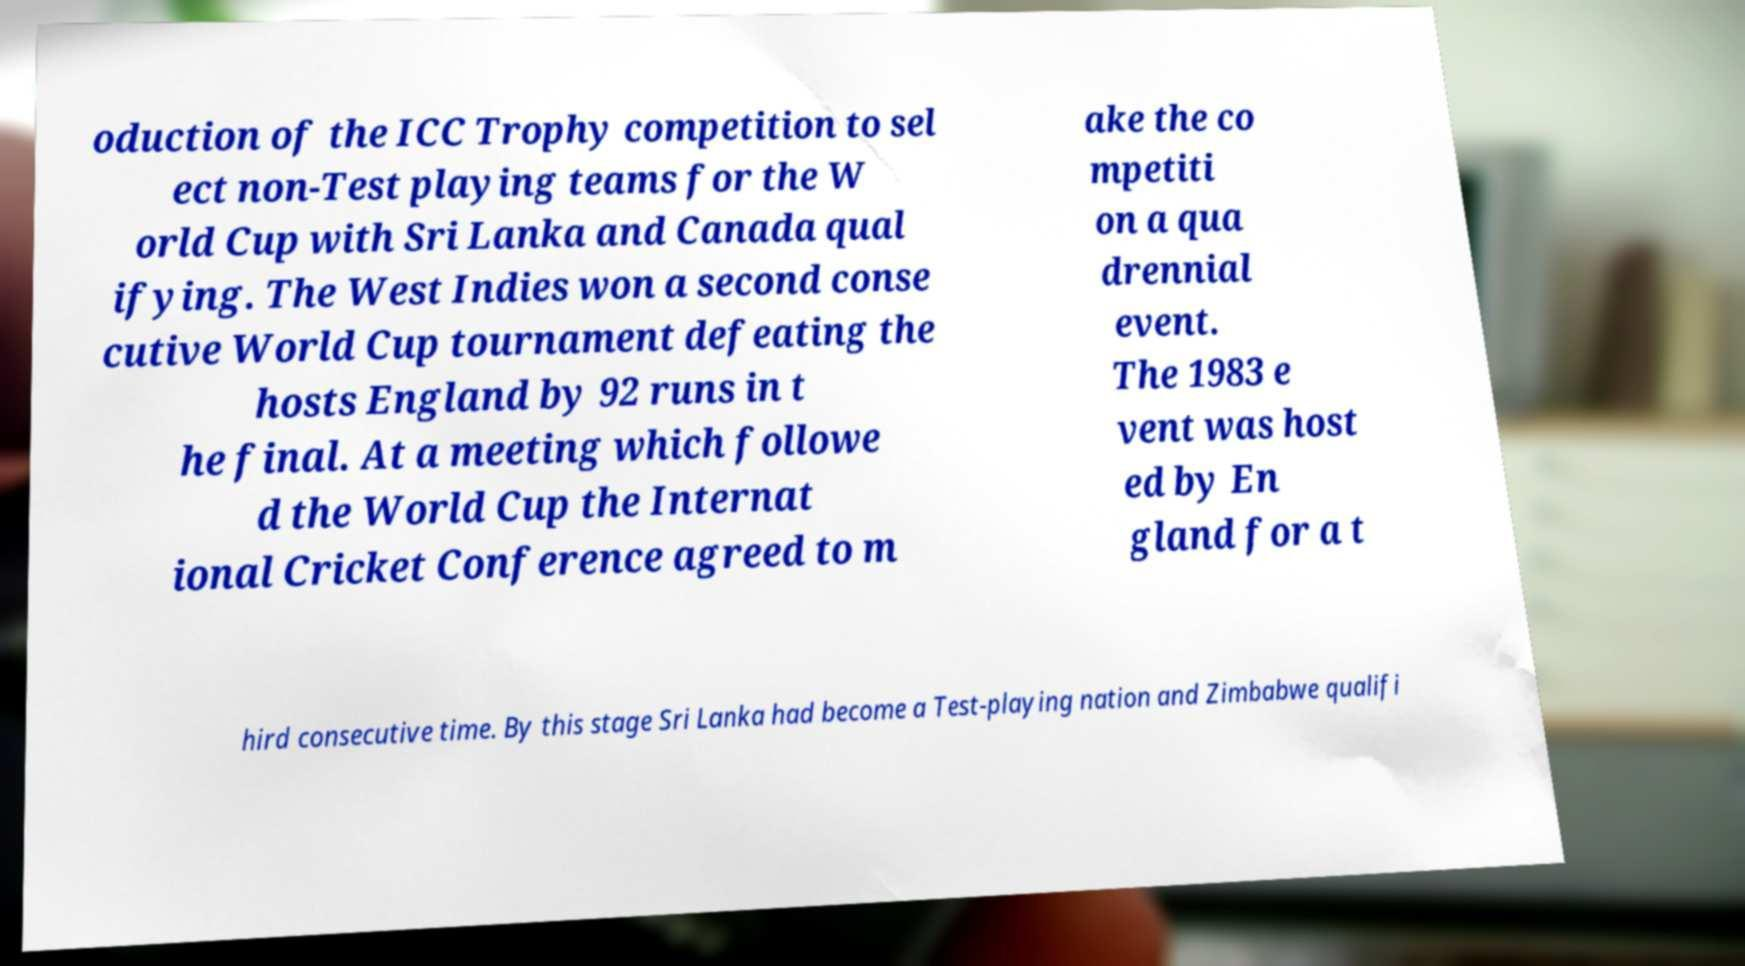What messages or text are displayed in this image? I need them in a readable, typed format. oduction of the ICC Trophy competition to sel ect non-Test playing teams for the W orld Cup with Sri Lanka and Canada qual ifying. The West Indies won a second conse cutive World Cup tournament defeating the hosts England by 92 runs in t he final. At a meeting which followe d the World Cup the Internat ional Cricket Conference agreed to m ake the co mpetiti on a qua drennial event. The 1983 e vent was host ed by En gland for a t hird consecutive time. By this stage Sri Lanka had become a Test-playing nation and Zimbabwe qualifi 